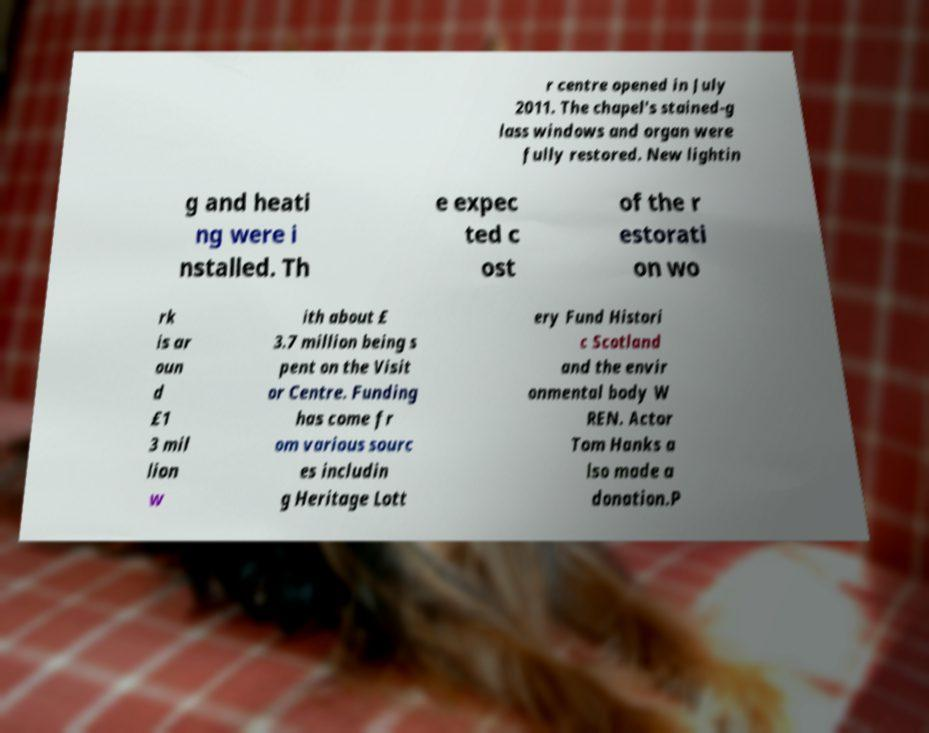There's text embedded in this image that I need extracted. Can you transcribe it verbatim? r centre opened in July 2011. The chapel's stained-g lass windows and organ were fully restored. New lightin g and heati ng were i nstalled. Th e expec ted c ost of the r estorati on wo rk is ar oun d £1 3 mil lion w ith about £ 3.7 million being s pent on the Visit or Centre. Funding has come fr om various sourc es includin g Heritage Lott ery Fund Histori c Scotland and the envir onmental body W REN. Actor Tom Hanks a lso made a donation.P 